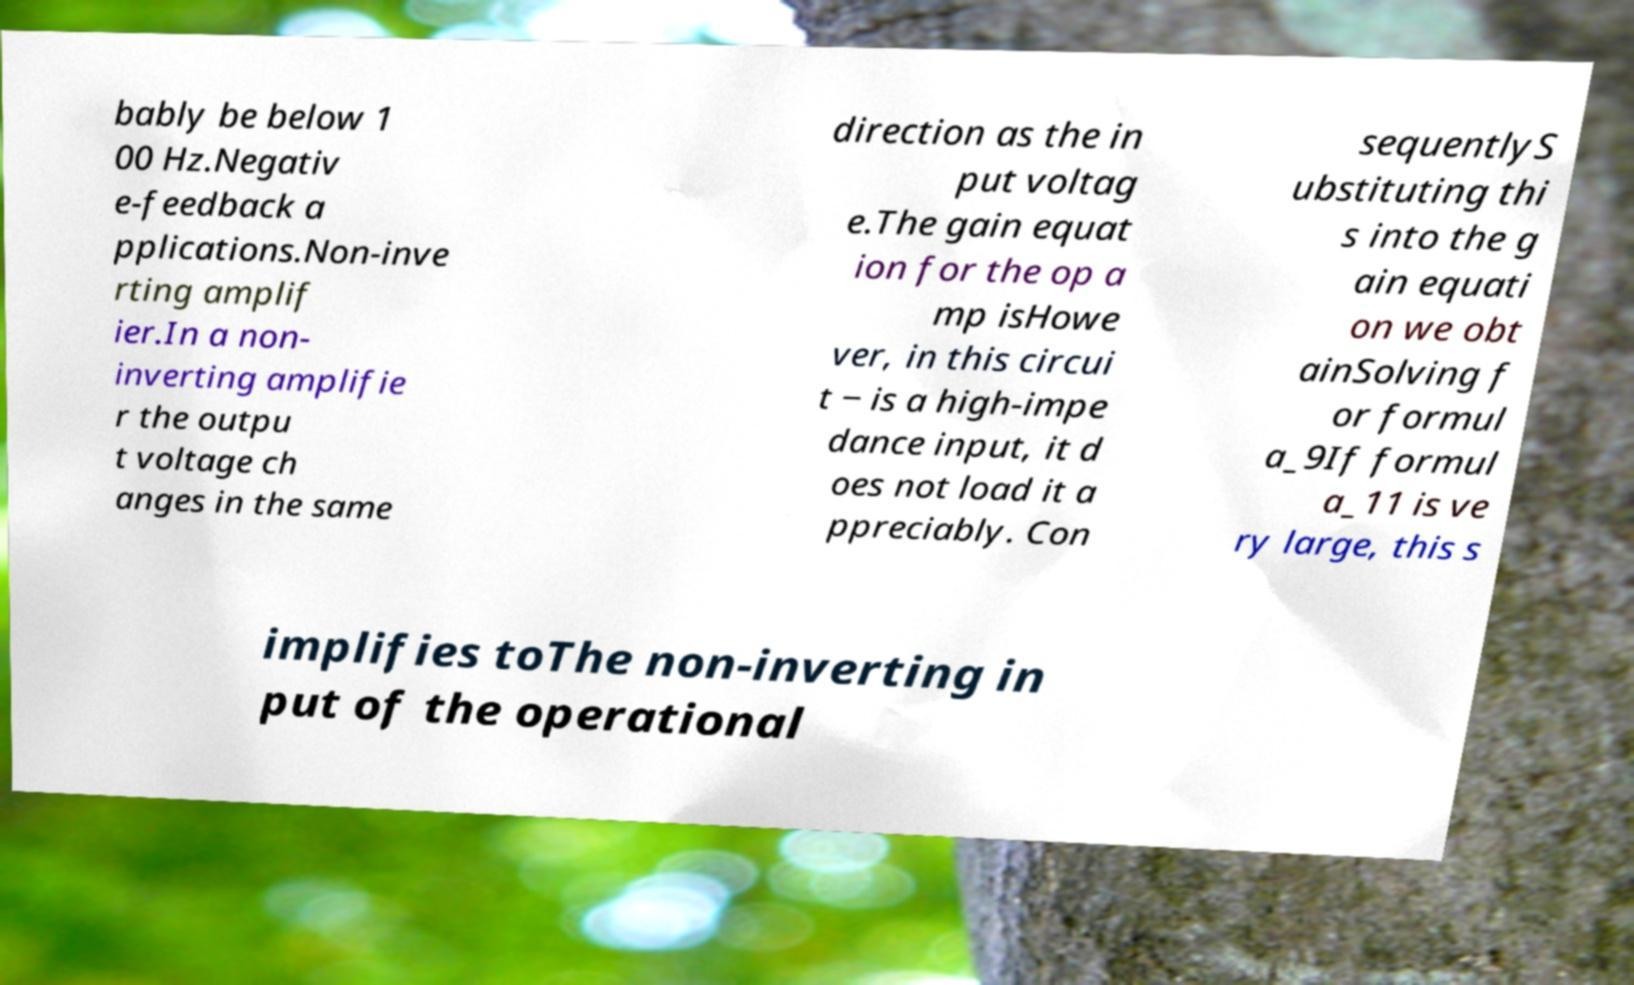Please identify and transcribe the text found in this image. bably be below 1 00 Hz.Negativ e-feedback a pplications.Non-inve rting amplif ier.In a non- inverting amplifie r the outpu t voltage ch anges in the same direction as the in put voltag e.The gain equat ion for the op a mp isHowe ver, in this circui t − is a high-impe dance input, it d oes not load it a ppreciably. Con sequentlyS ubstituting thi s into the g ain equati on we obt ainSolving f or formul a_9If formul a_11 is ve ry large, this s implifies toThe non-inverting in put of the operational 